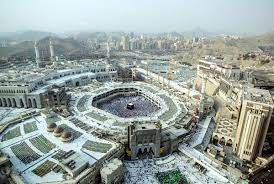Can you explain the architectural significance of the structures in this image? Certainly! The Great Mosque of Mecca is not only a spiritual center but also a marvel of Islamic architecture. The multiple minarets that rise around the mosque are predominantly Ottoman in style, symbolizing the Islamic tradition and its historical reach. The central Kaaba, clothed in its kiswah, is the most sacred site in Islam, where millions face during their prayers. Its simplicity contrasts with the complexity of the surrounding minarets and the sprawling white marble that accommodates countless worshippers, reflecting the blend of spirituality and communal unity in Islamic architectural design. 